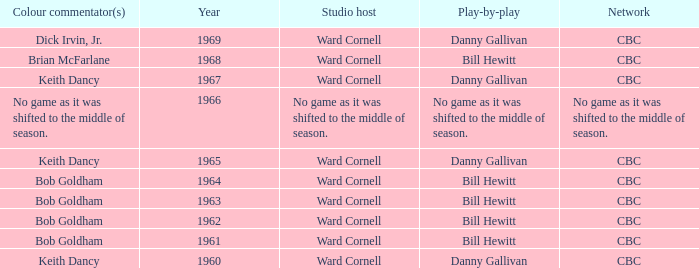Were the color commentators who worked with Bill Hewitt doing the play-by-play? Brian McFarlane, Bob Goldham, Bob Goldham, Bob Goldham, Bob Goldham. 